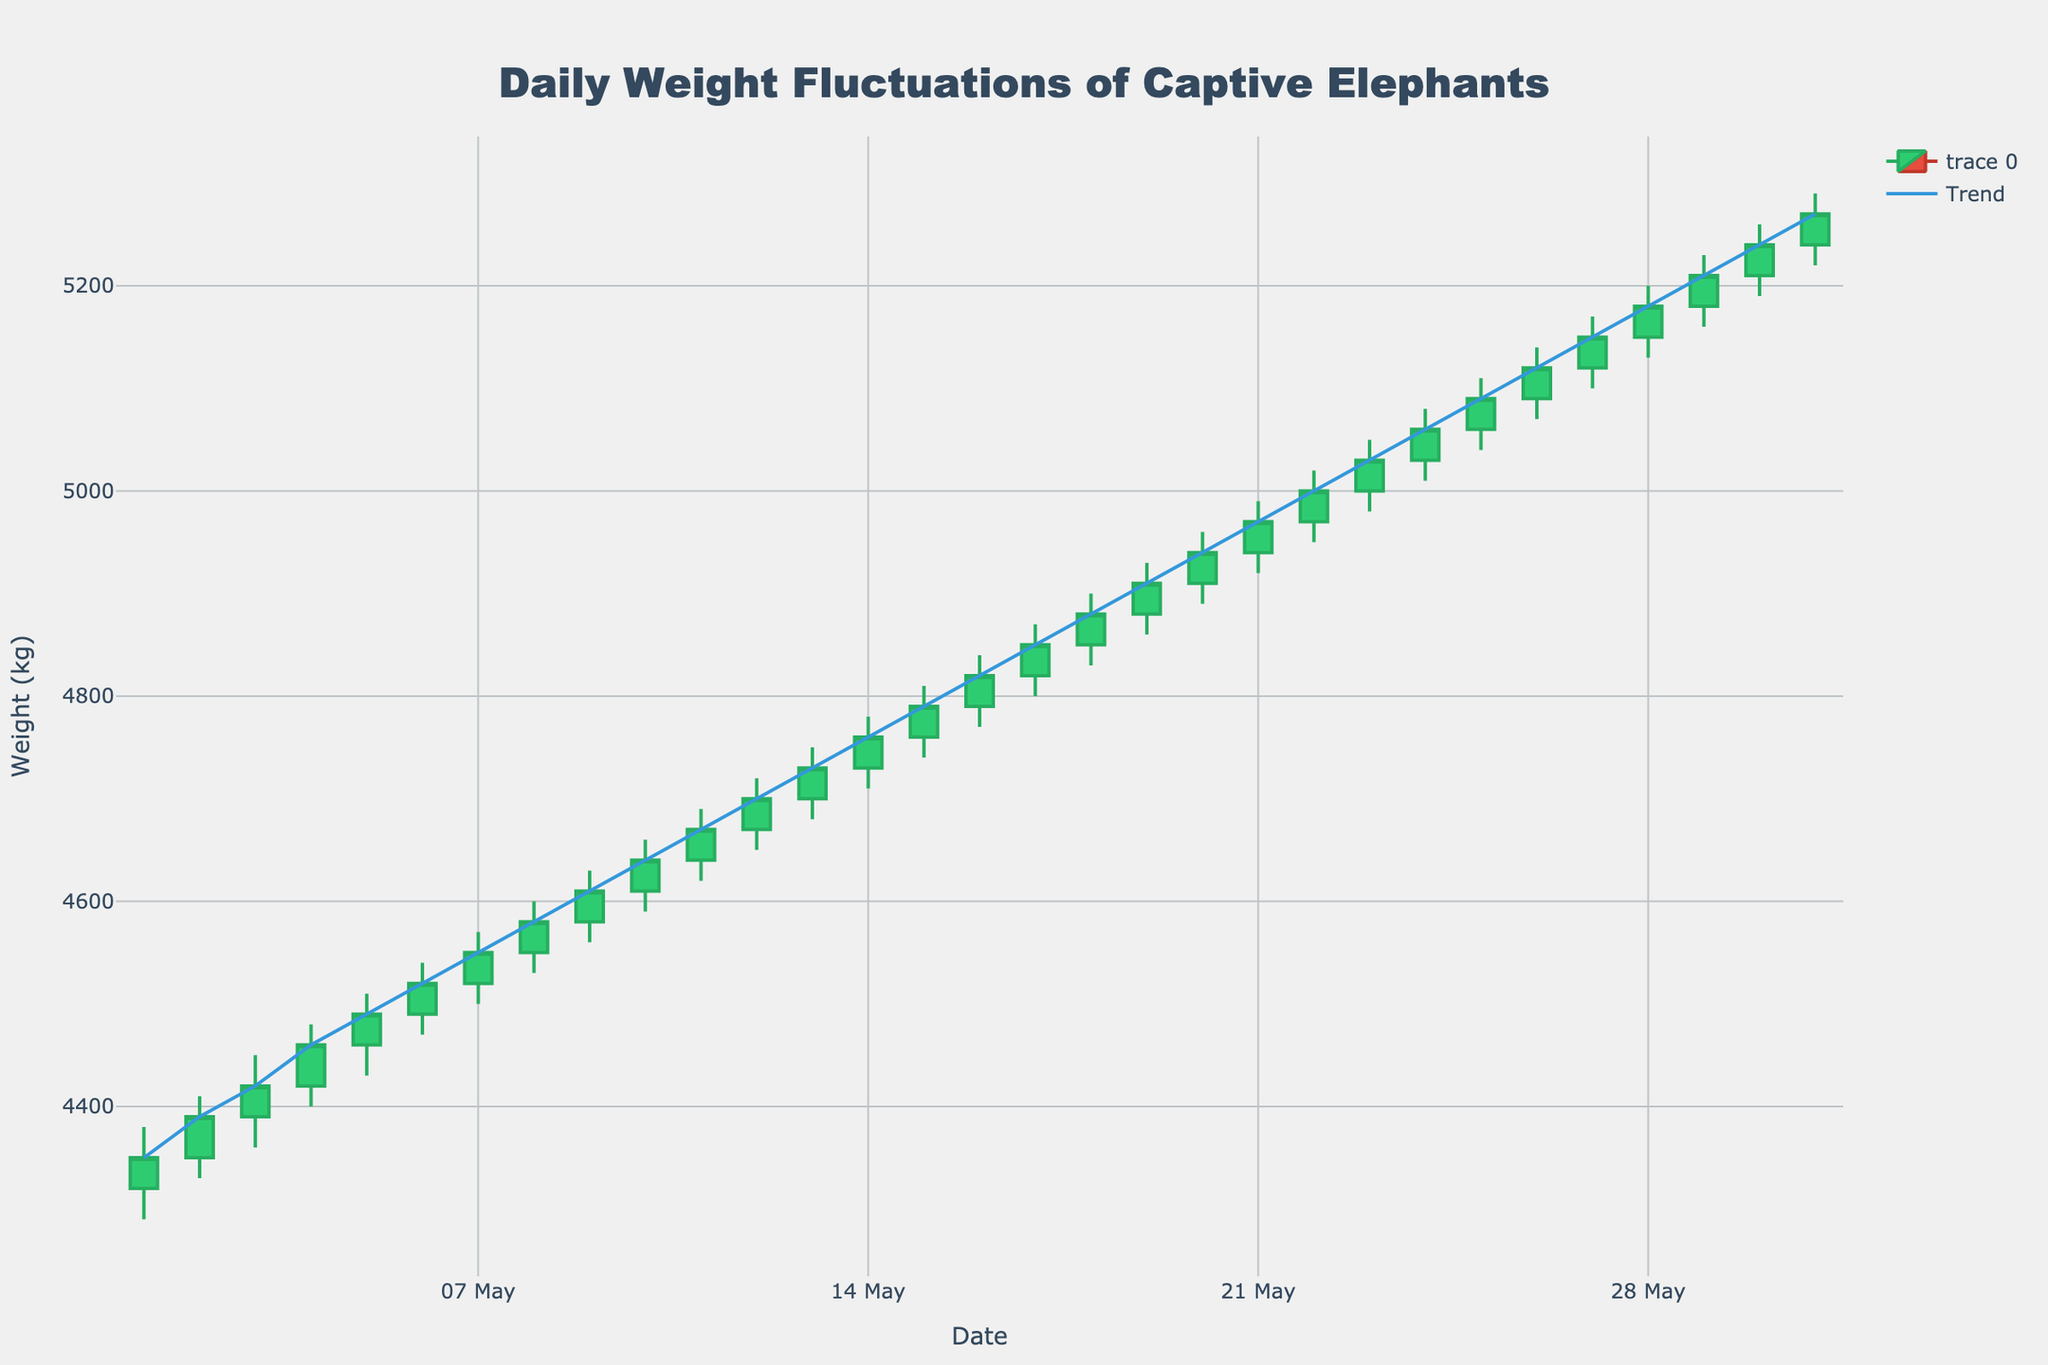What's the title of the figure? The title of the figure is located at the top and usually summarizes the contents of the chart. By reading the figure's title, you can understand what the chart is about.
Answer: Daily Weight Fluctuations of Captive Elephants What is the highest recorded weight on May 12th? To answer this question, locate May 12th on the x-axis, and then identify the highest point (High value) of the candlestick for that date.
Answer: 4720 kg How many days did the elephants' weight increase (Close > Open)? Count the number of days where the closing weight (Close) is greater than the opening weight (Open). This can be inferred by observing the candlestick colors, with green indicating an increase.
Answer: 31 days Which day recorded the largest single-day weight range, and what was the value? For each day, compute the weight range as the difference between the High and Low values. Identify which day has the largest difference.
Answer: May 31st, 70 kg What was the opening weight on May 20th and the closing weight on May 25th? Check the respective open and close values by locating May 20th and May 25th on the x-axis and reading the values.
Answer: 4910 kg, 5090 kg Describe the overall trend observed during the month. Examine the trend line added above the candlestick chart. Identify if the trend line shows an upward or downward movement over the month.
Answer: Upward trend How does the weight on May 1st compare to the weight on May 31st? To answer, compare the closing weight values of May 1st and May 31st.
Answer: May 31st is higher On which day was the lowest weight recorded, and what was the value? Locate the day with the lowest Low value by inspecting the minimum Low value across all dates.
Answer: May 1st, 4290 kg What was the average closing weight for the first week of May? Sum the closing weights for the dates from May 1st to May 7th, and then divide by the number of days (7).
Answer: 4470 kg Which days showed a decreasing trend in weight based on the closing values? Identify days where the candlestick is red, indicating the closing weight was lower than the opening weight.
Answer: No days 